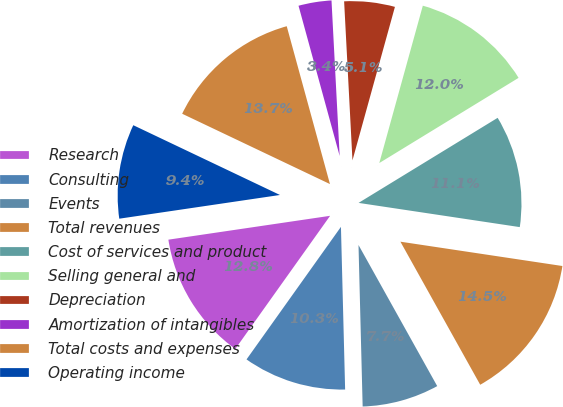Convert chart to OTSL. <chart><loc_0><loc_0><loc_500><loc_500><pie_chart><fcel>Research<fcel>Consulting<fcel>Events<fcel>Total revenues<fcel>Cost of services and product<fcel>Selling general and<fcel>Depreciation<fcel>Amortization of intangibles<fcel>Total costs and expenses<fcel>Operating income<nl><fcel>12.82%<fcel>10.26%<fcel>7.69%<fcel>14.53%<fcel>11.11%<fcel>11.97%<fcel>5.13%<fcel>3.42%<fcel>13.68%<fcel>9.4%<nl></chart> 